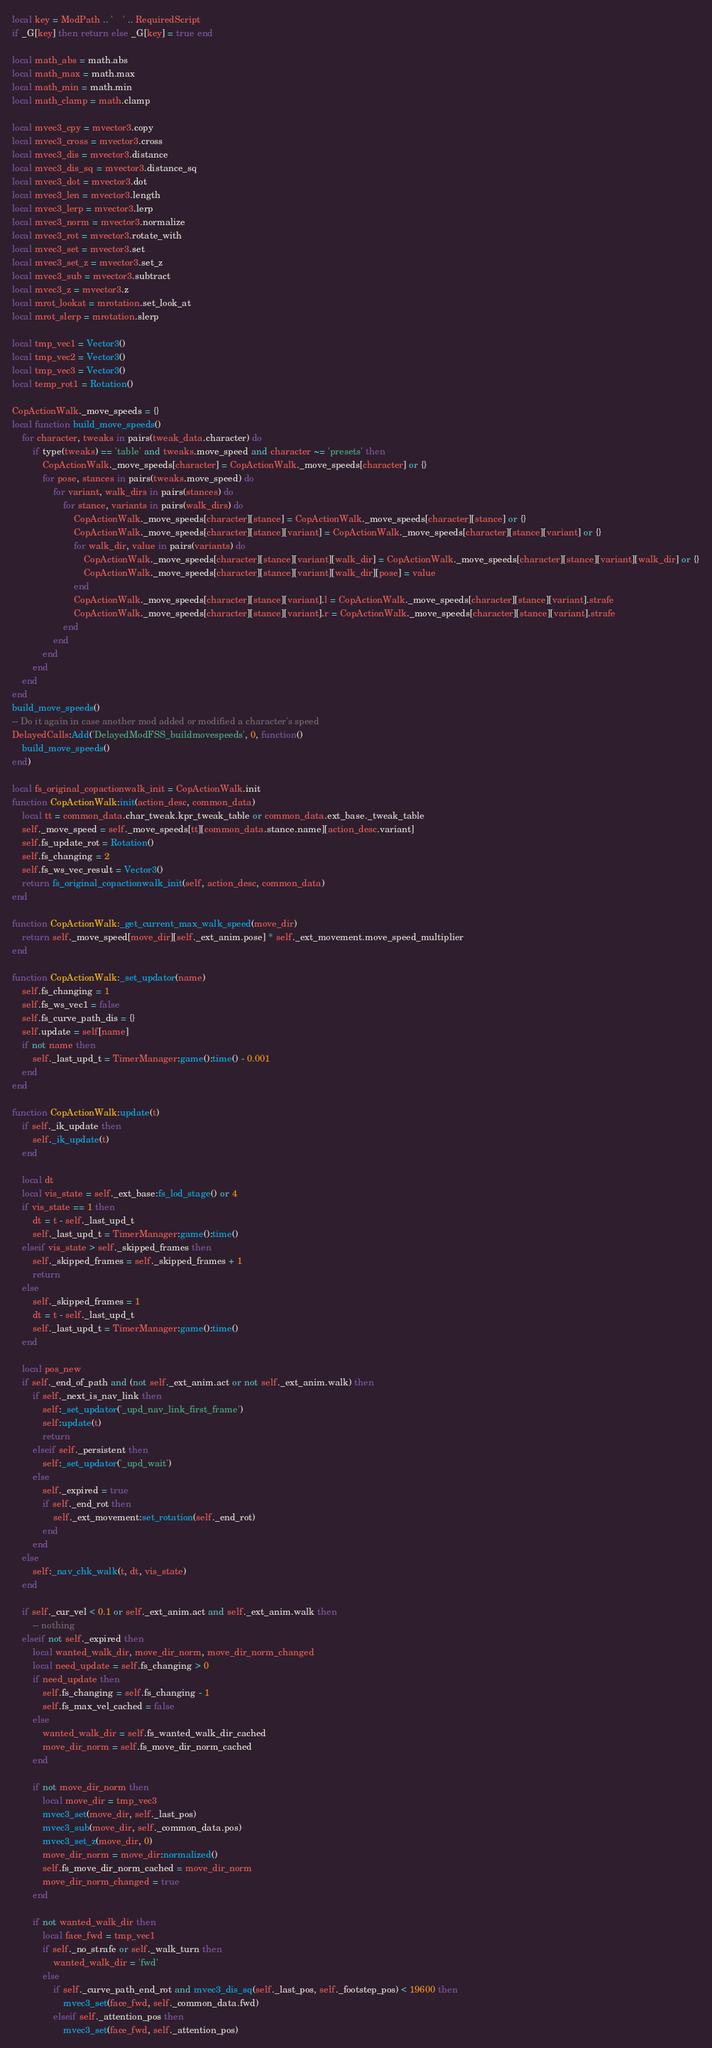<code> <loc_0><loc_0><loc_500><loc_500><_Lua_>local key = ModPath .. '	' .. RequiredScript
if _G[key] then return else _G[key] = true end

local math_abs = math.abs
local math_max = math.max
local math_min = math.min
local math_clamp = math.clamp

local mvec3_cpy = mvector3.copy
local mvec3_cross = mvector3.cross
local mvec3_dis = mvector3.distance
local mvec3_dis_sq = mvector3.distance_sq
local mvec3_dot = mvector3.dot
local mvec3_len = mvector3.length
local mvec3_lerp = mvector3.lerp
local mvec3_norm = mvector3.normalize
local mvec3_rot = mvector3.rotate_with
local mvec3_set = mvector3.set
local mvec3_set_z = mvector3.set_z
local mvec3_sub = mvector3.subtract
local mvec3_z = mvector3.z
local mrot_lookat = mrotation.set_look_at
local mrot_slerp = mrotation.slerp

local tmp_vec1 = Vector3()
local tmp_vec2 = Vector3()
local tmp_vec3 = Vector3()
local temp_rot1 = Rotation()

CopActionWalk._move_speeds = {}
local function build_move_speeds()
	for character, tweaks in pairs(tweak_data.character) do
		if type(tweaks) == 'table' and tweaks.move_speed and character ~= 'presets' then
			CopActionWalk._move_speeds[character] = CopActionWalk._move_speeds[character] or {}
			for pose, stances in pairs(tweaks.move_speed) do
				for variant, walk_dirs in pairs(stances) do
					for stance, variants in pairs(walk_dirs) do
						CopActionWalk._move_speeds[character][stance] = CopActionWalk._move_speeds[character][stance] or {}
						CopActionWalk._move_speeds[character][stance][variant] = CopActionWalk._move_speeds[character][stance][variant] or {}
						for walk_dir, value in pairs(variants) do
							CopActionWalk._move_speeds[character][stance][variant][walk_dir] = CopActionWalk._move_speeds[character][stance][variant][walk_dir] or {}
							CopActionWalk._move_speeds[character][stance][variant][walk_dir][pose] = value
						end
						CopActionWalk._move_speeds[character][stance][variant].l = CopActionWalk._move_speeds[character][stance][variant].strafe
						CopActionWalk._move_speeds[character][stance][variant].r = CopActionWalk._move_speeds[character][stance][variant].strafe
					end
				end
			end
		end
	end
end
build_move_speeds()
-- Do it again in case another mod added or modified a character's speed
DelayedCalls:Add('DelayedModFSS_buildmovespeeds', 0, function()
	build_move_speeds()
end)

local fs_original_copactionwalk_init = CopActionWalk.init
function CopActionWalk:init(action_desc, common_data)
	local tt = common_data.char_tweak.kpr_tweak_table or common_data.ext_base._tweak_table
	self._move_speed = self._move_speeds[tt][common_data.stance.name][action_desc.variant]
	self.fs_update_rot = Rotation()
	self.fs_changing = 2
	self.fs_ws_vec_result = Vector3()
	return fs_original_copactionwalk_init(self, action_desc, common_data)
end

function CopActionWalk:_get_current_max_walk_speed(move_dir)
	return self._move_speed[move_dir][self._ext_anim.pose] * self._ext_movement.move_speed_multiplier
end

function CopActionWalk:_set_updator(name)
	self.fs_changing = 1
	self.fs_ws_vec1 = false
	self.fs_curve_path_dis = {}
	self.update = self[name]
	if not name then
		self._last_upd_t = TimerManager:game():time() - 0.001
	end
end

function CopActionWalk:update(t)
	if self._ik_update then
		self._ik_update(t)
	end

	local dt
	local vis_state = self._ext_base:fs_lod_stage() or 4
	if vis_state == 1 then
		dt = t - self._last_upd_t
		self._last_upd_t = TimerManager:game():time()
	elseif vis_state > self._skipped_frames then
		self._skipped_frames = self._skipped_frames + 1
		return
	else
		self._skipped_frames = 1
		dt = t - self._last_upd_t
		self._last_upd_t = TimerManager:game():time()
	end

	local pos_new
	if self._end_of_path and (not self._ext_anim.act or not self._ext_anim.walk) then
		if self._next_is_nav_link then
			self:_set_updator('_upd_nav_link_first_frame')
			self:update(t)
			return
		elseif self._persistent then
			self:_set_updator('_upd_wait')
		else
			self._expired = true
			if self._end_rot then
				self._ext_movement:set_rotation(self._end_rot)
			end
		end
	else
		self:_nav_chk_walk(t, dt, vis_state)
	end

	if self._cur_vel < 0.1 or self._ext_anim.act and self._ext_anim.walk then
		-- nothing
	elseif not self._expired then
		local wanted_walk_dir, move_dir_norm, move_dir_norm_changed
		local need_update = self.fs_changing > 0
		if need_update then
			self.fs_changing = self.fs_changing - 1
			self.fs_max_vel_cached = false
		else
			wanted_walk_dir = self.fs_wanted_walk_dir_cached
			move_dir_norm = self.fs_move_dir_norm_cached
		end

		if not move_dir_norm then
			local move_dir = tmp_vec3
			mvec3_set(move_dir, self._last_pos)
			mvec3_sub(move_dir, self._common_data.pos)
			mvec3_set_z(move_dir, 0)
			move_dir_norm = move_dir:normalized()
			self.fs_move_dir_norm_cached = move_dir_norm
			move_dir_norm_changed = true
		end

		if not wanted_walk_dir then
			local face_fwd = tmp_vec1
			if self._no_strafe or self._walk_turn then
				wanted_walk_dir = 'fwd'
			else
				if self._curve_path_end_rot and mvec3_dis_sq(self._last_pos, self._footstep_pos) < 19600 then
					mvec3_set(face_fwd, self._common_data.fwd)
				elseif self._attention_pos then
					mvec3_set(face_fwd, self._attention_pos)</code> 